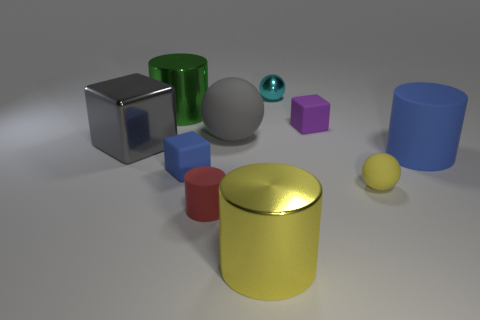Subtract 1 cylinders. How many cylinders are left? 3 Subtract all cylinders. How many objects are left? 6 Subtract 0 green balls. How many objects are left? 10 Subtract all yellow metallic things. Subtract all tiny metal cubes. How many objects are left? 9 Add 1 big gray matte balls. How many big gray matte balls are left? 2 Add 9 small cyan metal cubes. How many small cyan metal cubes exist? 9 